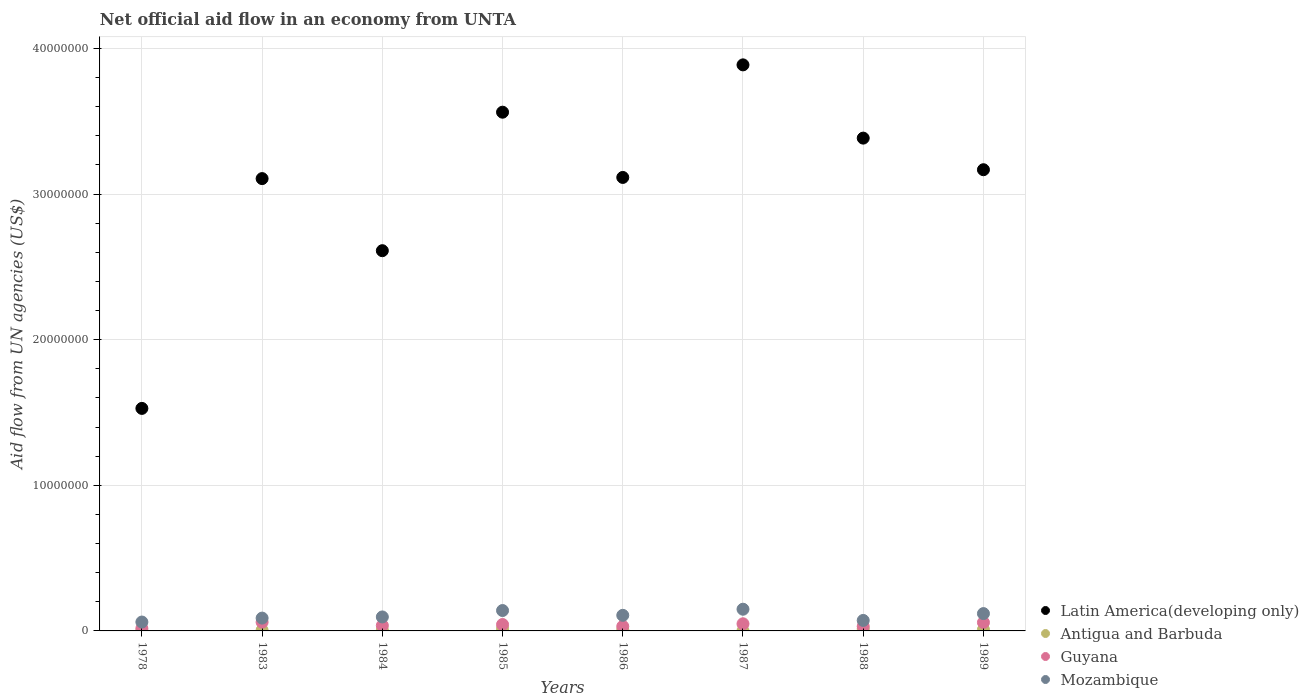What is the net official aid flow in Mozambique in 1983?
Ensure brevity in your answer.  8.80e+05. Across all years, what is the maximum net official aid flow in Antigua and Barbuda?
Provide a succinct answer. 1.60e+05. Across all years, what is the minimum net official aid flow in Mozambique?
Your answer should be compact. 6.10e+05. In which year was the net official aid flow in Guyana maximum?
Offer a terse response. 1983. In which year was the net official aid flow in Latin America(developing only) minimum?
Your answer should be very brief. 1978. What is the total net official aid flow in Mozambique in the graph?
Your response must be concise. 8.32e+06. What is the difference between the net official aid flow in Guyana in 1986 and the net official aid flow in Latin America(developing only) in 1987?
Provide a short and direct response. -3.86e+07. What is the average net official aid flow in Antigua and Barbuda per year?
Offer a very short reply. 7.50e+04. In the year 1978, what is the difference between the net official aid flow in Latin America(developing only) and net official aid flow in Mozambique?
Give a very brief answer. 1.47e+07. In how many years, is the net official aid flow in Mozambique greater than 6000000 US$?
Your answer should be very brief. 0. What is the ratio of the net official aid flow in Mozambique in 1985 to that in 1989?
Provide a succinct answer. 1.18. What is the difference between the highest and the lowest net official aid flow in Antigua and Barbuda?
Provide a succinct answer. 1.50e+05. In how many years, is the net official aid flow in Antigua and Barbuda greater than the average net official aid flow in Antigua and Barbuda taken over all years?
Give a very brief answer. 4. Is the sum of the net official aid flow in Antigua and Barbuda in 1985 and 1987 greater than the maximum net official aid flow in Mozambique across all years?
Your answer should be very brief. No. Is it the case that in every year, the sum of the net official aid flow in Mozambique and net official aid flow in Antigua and Barbuda  is greater than the sum of net official aid flow in Latin America(developing only) and net official aid flow in Guyana?
Offer a very short reply. No. Does the net official aid flow in Mozambique monotonically increase over the years?
Your answer should be compact. No. Is the net official aid flow in Guyana strictly greater than the net official aid flow in Antigua and Barbuda over the years?
Your answer should be very brief. Yes. Is the net official aid flow in Guyana strictly less than the net official aid flow in Mozambique over the years?
Your answer should be compact. Yes. How many dotlines are there?
Make the answer very short. 4. What is the difference between two consecutive major ticks on the Y-axis?
Give a very brief answer. 1.00e+07. Are the values on the major ticks of Y-axis written in scientific E-notation?
Your answer should be very brief. No. Does the graph contain grids?
Keep it short and to the point. Yes. Where does the legend appear in the graph?
Your response must be concise. Bottom right. How many legend labels are there?
Your answer should be very brief. 4. How are the legend labels stacked?
Make the answer very short. Vertical. What is the title of the graph?
Offer a very short reply. Net official aid flow in an economy from UNTA. Does "Sierra Leone" appear as one of the legend labels in the graph?
Offer a terse response. No. What is the label or title of the Y-axis?
Offer a terse response. Aid flow from UN agencies (US$). What is the Aid flow from UN agencies (US$) in Latin America(developing only) in 1978?
Offer a terse response. 1.53e+07. What is the Aid flow from UN agencies (US$) of Antigua and Barbuda in 1978?
Keep it short and to the point. 10000. What is the Aid flow from UN agencies (US$) in Guyana in 1978?
Ensure brevity in your answer.  1.70e+05. What is the Aid flow from UN agencies (US$) in Mozambique in 1978?
Your answer should be very brief. 6.10e+05. What is the Aid flow from UN agencies (US$) in Latin America(developing only) in 1983?
Make the answer very short. 3.11e+07. What is the Aid flow from UN agencies (US$) of Mozambique in 1983?
Your answer should be compact. 8.80e+05. What is the Aid flow from UN agencies (US$) of Latin America(developing only) in 1984?
Your answer should be very brief. 2.61e+07. What is the Aid flow from UN agencies (US$) of Antigua and Barbuda in 1984?
Ensure brevity in your answer.  6.00e+04. What is the Aid flow from UN agencies (US$) of Mozambique in 1984?
Provide a short and direct response. 9.60e+05. What is the Aid flow from UN agencies (US$) of Latin America(developing only) in 1985?
Provide a short and direct response. 3.56e+07. What is the Aid flow from UN agencies (US$) in Guyana in 1985?
Your response must be concise. 4.40e+05. What is the Aid flow from UN agencies (US$) in Mozambique in 1985?
Give a very brief answer. 1.40e+06. What is the Aid flow from UN agencies (US$) in Latin America(developing only) in 1986?
Your answer should be very brief. 3.11e+07. What is the Aid flow from UN agencies (US$) of Guyana in 1986?
Offer a very short reply. 3.10e+05. What is the Aid flow from UN agencies (US$) of Mozambique in 1986?
Provide a short and direct response. 1.07e+06. What is the Aid flow from UN agencies (US$) of Latin America(developing only) in 1987?
Give a very brief answer. 3.89e+07. What is the Aid flow from UN agencies (US$) in Mozambique in 1987?
Your response must be concise. 1.49e+06. What is the Aid flow from UN agencies (US$) in Latin America(developing only) in 1988?
Ensure brevity in your answer.  3.38e+07. What is the Aid flow from UN agencies (US$) of Antigua and Barbuda in 1988?
Provide a succinct answer. 1.40e+05. What is the Aid flow from UN agencies (US$) of Mozambique in 1988?
Your answer should be compact. 7.20e+05. What is the Aid flow from UN agencies (US$) of Latin America(developing only) in 1989?
Make the answer very short. 3.17e+07. What is the Aid flow from UN agencies (US$) in Guyana in 1989?
Your answer should be compact. 5.80e+05. What is the Aid flow from UN agencies (US$) of Mozambique in 1989?
Offer a very short reply. 1.19e+06. Across all years, what is the maximum Aid flow from UN agencies (US$) of Latin America(developing only)?
Provide a succinct answer. 3.89e+07. Across all years, what is the maximum Aid flow from UN agencies (US$) in Antigua and Barbuda?
Make the answer very short. 1.60e+05. Across all years, what is the maximum Aid flow from UN agencies (US$) in Mozambique?
Keep it short and to the point. 1.49e+06. Across all years, what is the minimum Aid flow from UN agencies (US$) in Latin America(developing only)?
Provide a short and direct response. 1.53e+07. What is the total Aid flow from UN agencies (US$) of Latin America(developing only) in the graph?
Your answer should be compact. 2.44e+08. What is the total Aid flow from UN agencies (US$) of Guyana in the graph?
Your response must be concise. 3.27e+06. What is the total Aid flow from UN agencies (US$) of Mozambique in the graph?
Provide a short and direct response. 8.32e+06. What is the difference between the Aid flow from UN agencies (US$) in Latin America(developing only) in 1978 and that in 1983?
Your response must be concise. -1.58e+07. What is the difference between the Aid flow from UN agencies (US$) of Antigua and Barbuda in 1978 and that in 1983?
Give a very brief answer. -4.00e+04. What is the difference between the Aid flow from UN agencies (US$) of Guyana in 1978 and that in 1983?
Offer a terse response. -4.30e+05. What is the difference between the Aid flow from UN agencies (US$) in Latin America(developing only) in 1978 and that in 1984?
Provide a short and direct response. -1.08e+07. What is the difference between the Aid flow from UN agencies (US$) in Mozambique in 1978 and that in 1984?
Keep it short and to the point. -3.50e+05. What is the difference between the Aid flow from UN agencies (US$) in Latin America(developing only) in 1978 and that in 1985?
Ensure brevity in your answer.  -2.03e+07. What is the difference between the Aid flow from UN agencies (US$) of Mozambique in 1978 and that in 1985?
Offer a terse response. -7.90e+05. What is the difference between the Aid flow from UN agencies (US$) in Latin America(developing only) in 1978 and that in 1986?
Keep it short and to the point. -1.59e+07. What is the difference between the Aid flow from UN agencies (US$) of Antigua and Barbuda in 1978 and that in 1986?
Provide a succinct answer. -7.00e+04. What is the difference between the Aid flow from UN agencies (US$) in Mozambique in 1978 and that in 1986?
Your answer should be compact. -4.60e+05. What is the difference between the Aid flow from UN agencies (US$) in Latin America(developing only) in 1978 and that in 1987?
Keep it short and to the point. -2.36e+07. What is the difference between the Aid flow from UN agencies (US$) in Antigua and Barbuda in 1978 and that in 1987?
Your answer should be very brief. 0. What is the difference between the Aid flow from UN agencies (US$) of Guyana in 1978 and that in 1987?
Your answer should be very brief. -3.20e+05. What is the difference between the Aid flow from UN agencies (US$) of Mozambique in 1978 and that in 1987?
Keep it short and to the point. -8.80e+05. What is the difference between the Aid flow from UN agencies (US$) in Latin America(developing only) in 1978 and that in 1988?
Offer a terse response. -1.86e+07. What is the difference between the Aid flow from UN agencies (US$) of Antigua and Barbuda in 1978 and that in 1988?
Your answer should be very brief. -1.30e+05. What is the difference between the Aid flow from UN agencies (US$) in Latin America(developing only) in 1978 and that in 1989?
Your answer should be compact. -1.64e+07. What is the difference between the Aid flow from UN agencies (US$) in Antigua and Barbuda in 1978 and that in 1989?
Your answer should be very brief. -8.00e+04. What is the difference between the Aid flow from UN agencies (US$) in Guyana in 1978 and that in 1989?
Keep it short and to the point. -4.10e+05. What is the difference between the Aid flow from UN agencies (US$) in Mozambique in 1978 and that in 1989?
Give a very brief answer. -5.80e+05. What is the difference between the Aid flow from UN agencies (US$) in Latin America(developing only) in 1983 and that in 1984?
Give a very brief answer. 4.95e+06. What is the difference between the Aid flow from UN agencies (US$) of Mozambique in 1983 and that in 1984?
Provide a succinct answer. -8.00e+04. What is the difference between the Aid flow from UN agencies (US$) of Latin America(developing only) in 1983 and that in 1985?
Offer a terse response. -4.56e+06. What is the difference between the Aid flow from UN agencies (US$) of Antigua and Barbuda in 1983 and that in 1985?
Keep it short and to the point. -1.10e+05. What is the difference between the Aid flow from UN agencies (US$) of Guyana in 1983 and that in 1985?
Your response must be concise. 1.60e+05. What is the difference between the Aid flow from UN agencies (US$) in Mozambique in 1983 and that in 1985?
Keep it short and to the point. -5.20e+05. What is the difference between the Aid flow from UN agencies (US$) in Latin America(developing only) in 1983 and that in 1986?
Your answer should be very brief. -8.00e+04. What is the difference between the Aid flow from UN agencies (US$) of Latin America(developing only) in 1983 and that in 1987?
Offer a very short reply. -7.81e+06. What is the difference between the Aid flow from UN agencies (US$) of Guyana in 1983 and that in 1987?
Provide a succinct answer. 1.10e+05. What is the difference between the Aid flow from UN agencies (US$) in Mozambique in 1983 and that in 1987?
Give a very brief answer. -6.10e+05. What is the difference between the Aid flow from UN agencies (US$) in Latin America(developing only) in 1983 and that in 1988?
Provide a succinct answer. -2.78e+06. What is the difference between the Aid flow from UN agencies (US$) of Mozambique in 1983 and that in 1988?
Provide a succinct answer. 1.60e+05. What is the difference between the Aid flow from UN agencies (US$) in Latin America(developing only) in 1983 and that in 1989?
Make the answer very short. -6.10e+05. What is the difference between the Aid flow from UN agencies (US$) of Guyana in 1983 and that in 1989?
Ensure brevity in your answer.  2.00e+04. What is the difference between the Aid flow from UN agencies (US$) in Mozambique in 1983 and that in 1989?
Provide a short and direct response. -3.10e+05. What is the difference between the Aid flow from UN agencies (US$) of Latin America(developing only) in 1984 and that in 1985?
Provide a succinct answer. -9.51e+06. What is the difference between the Aid flow from UN agencies (US$) of Mozambique in 1984 and that in 1985?
Keep it short and to the point. -4.40e+05. What is the difference between the Aid flow from UN agencies (US$) in Latin America(developing only) in 1984 and that in 1986?
Provide a succinct answer. -5.03e+06. What is the difference between the Aid flow from UN agencies (US$) of Guyana in 1984 and that in 1986?
Provide a succinct answer. 6.00e+04. What is the difference between the Aid flow from UN agencies (US$) in Mozambique in 1984 and that in 1986?
Offer a terse response. -1.10e+05. What is the difference between the Aid flow from UN agencies (US$) in Latin America(developing only) in 1984 and that in 1987?
Your answer should be very brief. -1.28e+07. What is the difference between the Aid flow from UN agencies (US$) of Mozambique in 1984 and that in 1987?
Your answer should be compact. -5.30e+05. What is the difference between the Aid flow from UN agencies (US$) of Latin America(developing only) in 1984 and that in 1988?
Your answer should be compact. -7.73e+06. What is the difference between the Aid flow from UN agencies (US$) in Guyana in 1984 and that in 1988?
Your answer should be very brief. 6.00e+04. What is the difference between the Aid flow from UN agencies (US$) in Latin America(developing only) in 1984 and that in 1989?
Offer a very short reply. -5.56e+06. What is the difference between the Aid flow from UN agencies (US$) of Antigua and Barbuda in 1984 and that in 1989?
Provide a succinct answer. -3.00e+04. What is the difference between the Aid flow from UN agencies (US$) of Latin America(developing only) in 1985 and that in 1986?
Offer a terse response. 4.48e+06. What is the difference between the Aid flow from UN agencies (US$) in Guyana in 1985 and that in 1986?
Your response must be concise. 1.30e+05. What is the difference between the Aid flow from UN agencies (US$) of Latin America(developing only) in 1985 and that in 1987?
Your response must be concise. -3.25e+06. What is the difference between the Aid flow from UN agencies (US$) in Antigua and Barbuda in 1985 and that in 1987?
Your answer should be very brief. 1.50e+05. What is the difference between the Aid flow from UN agencies (US$) of Guyana in 1985 and that in 1987?
Your answer should be very brief. -5.00e+04. What is the difference between the Aid flow from UN agencies (US$) in Latin America(developing only) in 1985 and that in 1988?
Offer a very short reply. 1.78e+06. What is the difference between the Aid flow from UN agencies (US$) in Antigua and Barbuda in 1985 and that in 1988?
Keep it short and to the point. 2.00e+04. What is the difference between the Aid flow from UN agencies (US$) in Guyana in 1985 and that in 1988?
Provide a succinct answer. 1.30e+05. What is the difference between the Aid flow from UN agencies (US$) in Mozambique in 1985 and that in 1988?
Your answer should be compact. 6.80e+05. What is the difference between the Aid flow from UN agencies (US$) of Latin America(developing only) in 1985 and that in 1989?
Your answer should be very brief. 3.95e+06. What is the difference between the Aid flow from UN agencies (US$) in Antigua and Barbuda in 1985 and that in 1989?
Your answer should be compact. 7.00e+04. What is the difference between the Aid flow from UN agencies (US$) of Mozambique in 1985 and that in 1989?
Ensure brevity in your answer.  2.10e+05. What is the difference between the Aid flow from UN agencies (US$) of Latin America(developing only) in 1986 and that in 1987?
Provide a succinct answer. -7.73e+06. What is the difference between the Aid flow from UN agencies (US$) in Mozambique in 1986 and that in 1987?
Your answer should be very brief. -4.20e+05. What is the difference between the Aid flow from UN agencies (US$) of Latin America(developing only) in 1986 and that in 1988?
Keep it short and to the point. -2.70e+06. What is the difference between the Aid flow from UN agencies (US$) of Antigua and Barbuda in 1986 and that in 1988?
Give a very brief answer. -6.00e+04. What is the difference between the Aid flow from UN agencies (US$) in Guyana in 1986 and that in 1988?
Your answer should be very brief. 0. What is the difference between the Aid flow from UN agencies (US$) of Mozambique in 1986 and that in 1988?
Offer a terse response. 3.50e+05. What is the difference between the Aid flow from UN agencies (US$) in Latin America(developing only) in 1986 and that in 1989?
Ensure brevity in your answer.  -5.30e+05. What is the difference between the Aid flow from UN agencies (US$) in Guyana in 1986 and that in 1989?
Keep it short and to the point. -2.70e+05. What is the difference between the Aid flow from UN agencies (US$) in Latin America(developing only) in 1987 and that in 1988?
Your answer should be very brief. 5.03e+06. What is the difference between the Aid flow from UN agencies (US$) of Antigua and Barbuda in 1987 and that in 1988?
Your answer should be compact. -1.30e+05. What is the difference between the Aid flow from UN agencies (US$) of Mozambique in 1987 and that in 1988?
Make the answer very short. 7.70e+05. What is the difference between the Aid flow from UN agencies (US$) of Latin America(developing only) in 1987 and that in 1989?
Give a very brief answer. 7.20e+06. What is the difference between the Aid flow from UN agencies (US$) in Mozambique in 1987 and that in 1989?
Provide a short and direct response. 3.00e+05. What is the difference between the Aid flow from UN agencies (US$) in Latin America(developing only) in 1988 and that in 1989?
Keep it short and to the point. 2.17e+06. What is the difference between the Aid flow from UN agencies (US$) in Antigua and Barbuda in 1988 and that in 1989?
Make the answer very short. 5.00e+04. What is the difference between the Aid flow from UN agencies (US$) in Guyana in 1988 and that in 1989?
Your response must be concise. -2.70e+05. What is the difference between the Aid flow from UN agencies (US$) in Mozambique in 1988 and that in 1989?
Provide a succinct answer. -4.70e+05. What is the difference between the Aid flow from UN agencies (US$) in Latin America(developing only) in 1978 and the Aid flow from UN agencies (US$) in Antigua and Barbuda in 1983?
Make the answer very short. 1.52e+07. What is the difference between the Aid flow from UN agencies (US$) in Latin America(developing only) in 1978 and the Aid flow from UN agencies (US$) in Guyana in 1983?
Offer a terse response. 1.47e+07. What is the difference between the Aid flow from UN agencies (US$) of Latin America(developing only) in 1978 and the Aid flow from UN agencies (US$) of Mozambique in 1983?
Make the answer very short. 1.44e+07. What is the difference between the Aid flow from UN agencies (US$) of Antigua and Barbuda in 1978 and the Aid flow from UN agencies (US$) of Guyana in 1983?
Your response must be concise. -5.90e+05. What is the difference between the Aid flow from UN agencies (US$) of Antigua and Barbuda in 1978 and the Aid flow from UN agencies (US$) of Mozambique in 1983?
Keep it short and to the point. -8.70e+05. What is the difference between the Aid flow from UN agencies (US$) in Guyana in 1978 and the Aid flow from UN agencies (US$) in Mozambique in 1983?
Provide a short and direct response. -7.10e+05. What is the difference between the Aid flow from UN agencies (US$) of Latin America(developing only) in 1978 and the Aid flow from UN agencies (US$) of Antigua and Barbuda in 1984?
Provide a short and direct response. 1.52e+07. What is the difference between the Aid flow from UN agencies (US$) in Latin America(developing only) in 1978 and the Aid flow from UN agencies (US$) in Guyana in 1984?
Give a very brief answer. 1.49e+07. What is the difference between the Aid flow from UN agencies (US$) of Latin America(developing only) in 1978 and the Aid flow from UN agencies (US$) of Mozambique in 1984?
Ensure brevity in your answer.  1.43e+07. What is the difference between the Aid flow from UN agencies (US$) of Antigua and Barbuda in 1978 and the Aid flow from UN agencies (US$) of Guyana in 1984?
Provide a succinct answer. -3.60e+05. What is the difference between the Aid flow from UN agencies (US$) of Antigua and Barbuda in 1978 and the Aid flow from UN agencies (US$) of Mozambique in 1984?
Your response must be concise. -9.50e+05. What is the difference between the Aid flow from UN agencies (US$) of Guyana in 1978 and the Aid flow from UN agencies (US$) of Mozambique in 1984?
Offer a very short reply. -7.90e+05. What is the difference between the Aid flow from UN agencies (US$) of Latin America(developing only) in 1978 and the Aid flow from UN agencies (US$) of Antigua and Barbuda in 1985?
Your response must be concise. 1.51e+07. What is the difference between the Aid flow from UN agencies (US$) in Latin America(developing only) in 1978 and the Aid flow from UN agencies (US$) in Guyana in 1985?
Make the answer very short. 1.48e+07. What is the difference between the Aid flow from UN agencies (US$) of Latin America(developing only) in 1978 and the Aid flow from UN agencies (US$) of Mozambique in 1985?
Provide a succinct answer. 1.39e+07. What is the difference between the Aid flow from UN agencies (US$) of Antigua and Barbuda in 1978 and the Aid flow from UN agencies (US$) of Guyana in 1985?
Your answer should be compact. -4.30e+05. What is the difference between the Aid flow from UN agencies (US$) in Antigua and Barbuda in 1978 and the Aid flow from UN agencies (US$) in Mozambique in 1985?
Make the answer very short. -1.39e+06. What is the difference between the Aid flow from UN agencies (US$) of Guyana in 1978 and the Aid flow from UN agencies (US$) of Mozambique in 1985?
Provide a short and direct response. -1.23e+06. What is the difference between the Aid flow from UN agencies (US$) in Latin America(developing only) in 1978 and the Aid flow from UN agencies (US$) in Antigua and Barbuda in 1986?
Provide a succinct answer. 1.52e+07. What is the difference between the Aid flow from UN agencies (US$) of Latin America(developing only) in 1978 and the Aid flow from UN agencies (US$) of Guyana in 1986?
Offer a terse response. 1.50e+07. What is the difference between the Aid flow from UN agencies (US$) of Latin America(developing only) in 1978 and the Aid flow from UN agencies (US$) of Mozambique in 1986?
Provide a short and direct response. 1.42e+07. What is the difference between the Aid flow from UN agencies (US$) in Antigua and Barbuda in 1978 and the Aid flow from UN agencies (US$) in Guyana in 1986?
Your response must be concise. -3.00e+05. What is the difference between the Aid flow from UN agencies (US$) of Antigua and Barbuda in 1978 and the Aid flow from UN agencies (US$) of Mozambique in 1986?
Provide a succinct answer. -1.06e+06. What is the difference between the Aid flow from UN agencies (US$) of Guyana in 1978 and the Aid flow from UN agencies (US$) of Mozambique in 1986?
Your response must be concise. -9.00e+05. What is the difference between the Aid flow from UN agencies (US$) in Latin America(developing only) in 1978 and the Aid flow from UN agencies (US$) in Antigua and Barbuda in 1987?
Provide a short and direct response. 1.53e+07. What is the difference between the Aid flow from UN agencies (US$) in Latin America(developing only) in 1978 and the Aid flow from UN agencies (US$) in Guyana in 1987?
Give a very brief answer. 1.48e+07. What is the difference between the Aid flow from UN agencies (US$) in Latin America(developing only) in 1978 and the Aid flow from UN agencies (US$) in Mozambique in 1987?
Ensure brevity in your answer.  1.38e+07. What is the difference between the Aid flow from UN agencies (US$) in Antigua and Barbuda in 1978 and the Aid flow from UN agencies (US$) in Guyana in 1987?
Offer a very short reply. -4.80e+05. What is the difference between the Aid flow from UN agencies (US$) in Antigua and Barbuda in 1978 and the Aid flow from UN agencies (US$) in Mozambique in 1987?
Provide a succinct answer. -1.48e+06. What is the difference between the Aid flow from UN agencies (US$) of Guyana in 1978 and the Aid flow from UN agencies (US$) of Mozambique in 1987?
Offer a very short reply. -1.32e+06. What is the difference between the Aid flow from UN agencies (US$) of Latin America(developing only) in 1978 and the Aid flow from UN agencies (US$) of Antigua and Barbuda in 1988?
Your response must be concise. 1.51e+07. What is the difference between the Aid flow from UN agencies (US$) in Latin America(developing only) in 1978 and the Aid flow from UN agencies (US$) in Guyana in 1988?
Provide a succinct answer. 1.50e+07. What is the difference between the Aid flow from UN agencies (US$) of Latin America(developing only) in 1978 and the Aid flow from UN agencies (US$) of Mozambique in 1988?
Keep it short and to the point. 1.46e+07. What is the difference between the Aid flow from UN agencies (US$) in Antigua and Barbuda in 1978 and the Aid flow from UN agencies (US$) in Mozambique in 1988?
Provide a succinct answer. -7.10e+05. What is the difference between the Aid flow from UN agencies (US$) of Guyana in 1978 and the Aid flow from UN agencies (US$) of Mozambique in 1988?
Offer a terse response. -5.50e+05. What is the difference between the Aid flow from UN agencies (US$) in Latin America(developing only) in 1978 and the Aid flow from UN agencies (US$) in Antigua and Barbuda in 1989?
Offer a terse response. 1.52e+07. What is the difference between the Aid flow from UN agencies (US$) in Latin America(developing only) in 1978 and the Aid flow from UN agencies (US$) in Guyana in 1989?
Provide a short and direct response. 1.47e+07. What is the difference between the Aid flow from UN agencies (US$) in Latin America(developing only) in 1978 and the Aid flow from UN agencies (US$) in Mozambique in 1989?
Keep it short and to the point. 1.41e+07. What is the difference between the Aid flow from UN agencies (US$) of Antigua and Barbuda in 1978 and the Aid flow from UN agencies (US$) of Guyana in 1989?
Provide a short and direct response. -5.70e+05. What is the difference between the Aid flow from UN agencies (US$) in Antigua and Barbuda in 1978 and the Aid flow from UN agencies (US$) in Mozambique in 1989?
Make the answer very short. -1.18e+06. What is the difference between the Aid flow from UN agencies (US$) of Guyana in 1978 and the Aid flow from UN agencies (US$) of Mozambique in 1989?
Your answer should be compact. -1.02e+06. What is the difference between the Aid flow from UN agencies (US$) of Latin America(developing only) in 1983 and the Aid flow from UN agencies (US$) of Antigua and Barbuda in 1984?
Ensure brevity in your answer.  3.10e+07. What is the difference between the Aid flow from UN agencies (US$) in Latin America(developing only) in 1983 and the Aid flow from UN agencies (US$) in Guyana in 1984?
Provide a succinct answer. 3.07e+07. What is the difference between the Aid flow from UN agencies (US$) in Latin America(developing only) in 1983 and the Aid flow from UN agencies (US$) in Mozambique in 1984?
Provide a short and direct response. 3.01e+07. What is the difference between the Aid flow from UN agencies (US$) in Antigua and Barbuda in 1983 and the Aid flow from UN agencies (US$) in Guyana in 1984?
Offer a very short reply. -3.20e+05. What is the difference between the Aid flow from UN agencies (US$) of Antigua and Barbuda in 1983 and the Aid flow from UN agencies (US$) of Mozambique in 1984?
Provide a short and direct response. -9.10e+05. What is the difference between the Aid flow from UN agencies (US$) of Guyana in 1983 and the Aid flow from UN agencies (US$) of Mozambique in 1984?
Your answer should be very brief. -3.60e+05. What is the difference between the Aid flow from UN agencies (US$) of Latin America(developing only) in 1983 and the Aid flow from UN agencies (US$) of Antigua and Barbuda in 1985?
Offer a very short reply. 3.09e+07. What is the difference between the Aid flow from UN agencies (US$) in Latin America(developing only) in 1983 and the Aid flow from UN agencies (US$) in Guyana in 1985?
Keep it short and to the point. 3.06e+07. What is the difference between the Aid flow from UN agencies (US$) of Latin America(developing only) in 1983 and the Aid flow from UN agencies (US$) of Mozambique in 1985?
Provide a short and direct response. 2.97e+07. What is the difference between the Aid flow from UN agencies (US$) in Antigua and Barbuda in 1983 and the Aid flow from UN agencies (US$) in Guyana in 1985?
Your response must be concise. -3.90e+05. What is the difference between the Aid flow from UN agencies (US$) of Antigua and Barbuda in 1983 and the Aid flow from UN agencies (US$) of Mozambique in 1985?
Provide a succinct answer. -1.35e+06. What is the difference between the Aid flow from UN agencies (US$) in Guyana in 1983 and the Aid flow from UN agencies (US$) in Mozambique in 1985?
Make the answer very short. -8.00e+05. What is the difference between the Aid flow from UN agencies (US$) in Latin America(developing only) in 1983 and the Aid flow from UN agencies (US$) in Antigua and Barbuda in 1986?
Offer a terse response. 3.10e+07. What is the difference between the Aid flow from UN agencies (US$) in Latin America(developing only) in 1983 and the Aid flow from UN agencies (US$) in Guyana in 1986?
Your answer should be very brief. 3.08e+07. What is the difference between the Aid flow from UN agencies (US$) in Latin America(developing only) in 1983 and the Aid flow from UN agencies (US$) in Mozambique in 1986?
Offer a terse response. 3.00e+07. What is the difference between the Aid flow from UN agencies (US$) of Antigua and Barbuda in 1983 and the Aid flow from UN agencies (US$) of Guyana in 1986?
Your answer should be very brief. -2.60e+05. What is the difference between the Aid flow from UN agencies (US$) of Antigua and Barbuda in 1983 and the Aid flow from UN agencies (US$) of Mozambique in 1986?
Offer a terse response. -1.02e+06. What is the difference between the Aid flow from UN agencies (US$) in Guyana in 1983 and the Aid flow from UN agencies (US$) in Mozambique in 1986?
Offer a very short reply. -4.70e+05. What is the difference between the Aid flow from UN agencies (US$) in Latin America(developing only) in 1983 and the Aid flow from UN agencies (US$) in Antigua and Barbuda in 1987?
Your answer should be very brief. 3.10e+07. What is the difference between the Aid flow from UN agencies (US$) of Latin America(developing only) in 1983 and the Aid flow from UN agencies (US$) of Guyana in 1987?
Offer a very short reply. 3.06e+07. What is the difference between the Aid flow from UN agencies (US$) of Latin America(developing only) in 1983 and the Aid flow from UN agencies (US$) of Mozambique in 1987?
Make the answer very short. 2.96e+07. What is the difference between the Aid flow from UN agencies (US$) in Antigua and Barbuda in 1983 and the Aid flow from UN agencies (US$) in Guyana in 1987?
Ensure brevity in your answer.  -4.40e+05. What is the difference between the Aid flow from UN agencies (US$) of Antigua and Barbuda in 1983 and the Aid flow from UN agencies (US$) of Mozambique in 1987?
Your answer should be compact. -1.44e+06. What is the difference between the Aid flow from UN agencies (US$) of Guyana in 1983 and the Aid flow from UN agencies (US$) of Mozambique in 1987?
Ensure brevity in your answer.  -8.90e+05. What is the difference between the Aid flow from UN agencies (US$) of Latin America(developing only) in 1983 and the Aid flow from UN agencies (US$) of Antigua and Barbuda in 1988?
Make the answer very short. 3.09e+07. What is the difference between the Aid flow from UN agencies (US$) of Latin America(developing only) in 1983 and the Aid flow from UN agencies (US$) of Guyana in 1988?
Your answer should be very brief. 3.08e+07. What is the difference between the Aid flow from UN agencies (US$) of Latin America(developing only) in 1983 and the Aid flow from UN agencies (US$) of Mozambique in 1988?
Make the answer very short. 3.03e+07. What is the difference between the Aid flow from UN agencies (US$) of Antigua and Barbuda in 1983 and the Aid flow from UN agencies (US$) of Mozambique in 1988?
Ensure brevity in your answer.  -6.70e+05. What is the difference between the Aid flow from UN agencies (US$) in Latin America(developing only) in 1983 and the Aid flow from UN agencies (US$) in Antigua and Barbuda in 1989?
Your answer should be very brief. 3.10e+07. What is the difference between the Aid flow from UN agencies (US$) in Latin America(developing only) in 1983 and the Aid flow from UN agencies (US$) in Guyana in 1989?
Keep it short and to the point. 3.05e+07. What is the difference between the Aid flow from UN agencies (US$) in Latin America(developing only) in 1983 and the Aid flow from UN agencies (US$) in Mozambique in 1989?
Your answer should be compact. 2.99e+07. What is the difference between the Aid flow from UN agencies (US$) of Antigua and Barbuda in 1983 and the Aid flow from UN agencies (US$) of Guyana in 1989?
Offer a very short reply. -5.30e+05. What is the difference between the Aid flow from UN agencies (US$) in Antigua and Barbuda in 1983 and the Aid flow from UN agencies (US$) in Mozambique in 1989?
Ensure brevity in your answer.  -1.14e+06. What is the difference between the Aid flow from UN agencies (US$) of Guyana in 1983 and the Aid flow from UN agencies (US$) of Mozambique in 1989?
Provide a short and direct response. -5.90e+05. What is the difference between the Aid flow from UN agencies (US$) of Latin America(developing only) in 1984 and the Aid flow from UN agencies (US$) of Antigua and Barbuda in 1985?
Ensure brevity in your answer.  2.60e+07. What is the difference between the Aid flow from UN agencies (US$) of Latin America(developing only) in 1984 and the Aid flow from UN agencies (US$) of Guyana in 1985?
Offer a very short reply. 2.57e+07. What is the difference between the Aid flow from UN agencies (US$) in Latin America(developing only) in 1984 and the Aid flow from UN agencies (US$) in Mozambique in 1985?
Offer a very short reply. 2.47e+07. What is the difference between the Aid flow from UN agencies (US$) of Antigua and Barbuda in 1984 and the Aid flow from UN agencies (US$) of Guyana in 1985?
Your answer should be compact. -3.80e+05. What is the difference between the Aid flow from UN agencies (US$) in Antigua and Barbuda in 1984 and the Aid flow from UN agencies (US$) in Mozambique in 1985?
Give a very brief answer. -1.34e+06. What is the difference between the Aid flow from UN agencies (US$) in Guyana in 1984 and the Aid flow from UN agencies (US$) in Mozambique in 1985?
Offer a terse response. -1.03e+06. What is the difference between the Aid flow from UN agencies (US$) of Latin America(developing only) in 1984 and the Aid flow from UN agencies (US$) of Antigua and Barbuda in 1986?
Provide a short and direct response. 2.60e+07. What is the difference between the Aid flow from UN agencies (US$) in Latin America(developing only) in 1984 and the Aid flow from UN agencies (US$) in Guyana in 1986?
Provide a short and direct response. 2.58e+07. What is the difference between the Aid flow from UN agencies (US$) of Latin America(developing only) in 1984 and the Aid flow from UN agencies (US$) of Mozambique in 1986?
Your answer should be very brief. 2.50e+07. What is the difference between the Aid flow from UN agencies (US$) in Antigua and Barbuda in 1984 and the Aid flow from UN agencies (US$) in Guyana in 1986?
Your answer should be very brief. -2.50e+05. What is the difference between the Aid flow from UN agencies (US$) of Antigua and Barbuda in 1984 and the Aid flow from UN agencies (US$) of Mozambique in 1986?
Offer a terse response. -1.01e+06. What is the difference between the Aid flow from UN agencies (US$) of Guyana in 1984 and the Aid flow from UN agencies (US$) of Mozambique in 1986?
Provide a succinct answer. -7.00e+05. What is the difference between the Aid flow from UN agencies (US$) of Latin America(developing only) in 1984 and the Aid flow from UN agencies (US$) of Antigua and Barbuda in 1987?
Your answer should be very brief. 2.61e+07. What is the difference between the Aid flow from UN agencies (US$) in Latin America(developing only) in 1984 and the Aid flow from UN agencies (US$) in Guyana in 1987?
Keep it short and to the point. 2.56e+07. What is the difference between the Aid flow from UN agencies (US$) in Latin America(developing only) in 1984 and the Aid flow from UN agencies (US$) in Mozambique in 1987?
Give a very brief answer. 2.46e+07. What is the difference between the Aid flow from UN agencies (US$) of Antigua and Barbuda in 1984 and the Aid flow from UN agencies (US$) of Guyana in 1987?
Provide a succinct answer. -4.30e+05. What is the difference between the Aid flow from UN agencies (US$) of Antigua and Barbuda in 1984 and the Aid flow from UN agencies (US$) of Mozambique in 1987?
Provide a short and direct response. -1.43e+06. What is the difference between the Aid flow from UN agencies (US$) of Guyana in 1984 and the Aid flow from UN agencies (US$) of Mozambique in 1987?
Keep it short and to the point. -1.12e+06. What is the difference between the Aid flow from UN agencies (US$) of Latin America(developing only) in 1984 and the Aid flow from UN agencies (US$) of Antigua and Barbuda in 1988?
Provide a short and direct response. 2.60e+07. What is the difference between the Aid flow from UN agencies (US$) in Latin America(developing only) in 1984 and the Aid flow from UN agencies (US$) in Guyana in 1988?
Give a very brief answer. 2.58e+07. What is the difference between the Aid flow from UN agencies (US$) of Latin America(developing only) in 1984 and the Aid flow from UN agencies (US$) of Mozambique in 1988?
Make the answer very short. 2.54e+07. What is the difference between the Aid flow from UN agencies (US$) in Antigua and Barbuda in 1984 and the Aid flow from UN agencies (US$) in Mozambique in 1988?
Keep it short and to the point. -6.60e+05. What is the difference between the Aid flow from UN agencies (US$) in Guyana in 1984 and the Aid flow from UN agencies (US$) in Mozambique in 1988?
Your answer should be very brief. -3.50e+05. What is the difference between the Aid flow from UN agencies (US$) of Latin America(developing only) in 1984 and the Aid flow from UN agencies (US$) of Antigua and Barbuda in 1989?
Your response must be concise. 2.60e+07. What is the difference between the Aid flow from UN agencies (US$) of Latin America(developing only) in 1984 and the Aid flow from UN agencies (US$) of Guyana in 1989?
Provide a succinct answer. 2.55e+07. What is the difference between the Aid flow from UN agencies (US$) of Latin America(developing only) in 1984 and the Aid flow from UN agencies (US$) of Mozambique in 1989?
Keep it short and to the point. 2.49e+07. What is the difference between the Aid flow from UN agencies (US$) of Antigua and Barbuda in 1984 and the Aid flow from UN agencies (US$) of Guyana in 1989?
Your answer should be compact. -5.20e+05. What is the difference between the Aid flow from UN agencies (US$) in Antigua and Barbuda in 1984 and the Aid flow from UN agencies (US$) in Mozambique in 1989?
Keep it short and to the point. -1.13e+06. What is the difference between the Aid flow from UN agencies (US$) of Guyana in 1984 and the Aid flow from UN agencies (US$) of Mozambique in 1989?
Provide a short and direct response. -8.20e+05. What is the difference between the Aid flow from UN agencies (US$) of Latin America(developing only) in 1985 and the Aid flow from UN agencies (US$) of Antigua and Barbuda in 1986?
Give a very brief answer. 3.55e+07. What is the difference between the Aid flow from UN agencies (US$) in Latin America(developing only) in 1985 and the Aid flow from UN agencies (US$) in Guyana in 1986?
Your response must be concise. 3.53e+07. What is the difference between the Aid flow from UN agencies (US$) of Latin America(developing only) in 1985 and the Aid flow from UN agencies (US$) of Mozambique in 1986?
Give a very brief answer. 3.46e+07. What is the difference between the Aid flow from UN agencies (US$) in Antigua and Barbuda in 1985 and the Aid flow from UN agencies (US$) in Mozambique in 1986?
Your answer should be compact. -9.10e+05. What is the difference between the Aid flow from UN agencies (US$) in Guyana in 1985 and the Aid flow from UN agencies (US$) in Mozambique in 1986?
Give a very brief answer. -6.30e+05. What is the difference between the Aid flow from UN agencies (US$) of Latin America(developing only) in 1985 and the Aid flow from UN agencies (US$) of Antigua and Barbuda in 1987?
Your response must be concise. 3.56e+07. What is the difference between the Aid flow from UN agencies (US$) in Latin America(developing only) in 1985 and the Aid flow from UN agencies (US$) in Guyana in 1987?
Provide a succinct answer. 3.51e+07. What is the difference between the Aid flow from UN agencies (US$) of Latin America(developing only) in 1985 and the Aid flow from UN agencies (US$) of Mozambique in 1987?
Keep it short and to the point. 3.41e+07. What is the difference between the Aid flow from UN agencies (US$) in Antigua and Barbuda in 1985 and the Aid flow from UN agencies (US$) in Guyana in 1987?
Your response must be concise. -3.30e+05. What is the difference between the Aid flow from UN agencies (US$) in Antigua and Barbuda in 1985 and the Aid flow from UN agencies (US$) in Mozambique in 1987?
Make the answer very short. -1.33e+06. What is the difference between the Aid flow from UN agencies (US$) of Guyana in 1985 and the Aid flow from UN agencies (US$) of Mozambique in 1987?
Provide a short and direct response. -1.05e+06. What is the difference between the Aid flow from UN agencies (US$) of Latin America(developing only) in 1985 and the Aid flow from UN agencies (US$) of Antigua and Barbuda in 1988?
Your response must be concise. 3.55e+07. What is the difference between the Aid flow from UN agencies (US$) of Latin America(developing only) in 1985 and the Aid flow from UN agencies (US$) of Guyana in 1988?
Your answer should be very brief. 3.53e+07. What is the difference between the Aid flow from UN agencies (US$) in Latin America(developing only) in 1985 and the Aid flow from UN agencies (US$) in Mozambique in 1988?
Keep it short and to the point. 3.49e+07. What is the difference between the Aid flow from UN agencies (US$) of Antigua and Barbuda in 1985 and the Aid flow from UN agencies (US$) of Mozambique in 1988?
Provide a succinct answer. -5.60e+05. What is the difference between the Aid flow from UN agencies (US$) of Guyana in 1985 and the Aid flow from UN agencies (US$) of Mozambique in 1988?
Your answer should be compact. -2.80e+05. What is the difference between the Aid flow from UN agencies (US$) of Latin America(developing only) in 1985 and the Aid flow from UN agencies (US$) of Antigua and Barbuda in 1989?
Keep it short and to the point. 3.55e+07. What is the difference between the Aid flow from UN agencies (US$) of Latin America(developing only) in 1985 and the Aid flow from UN agencies (US$) of Guyana in 1989?
Ensure brevity in your answer.  3.50e+07. What is the difference between the Aid flow from UN agencies (US$) in Latin America(developing only) in 1985 and the Aid flow from UN agencies (US$) in Mozambique in 1989?
Provide a short and direct response. 3.44e+07. What is the difference between the Aid flow from UN agencies (US$) of Antigua and Barbuda in 1985 and the Aid flow from UN agencies (US$) of Guyana in 1989?
Give a very brief answer. -4.20e+05. What is the difference between the Aid flow from UN agencies (US$) in Antigua and Barbuda in 1985 and the Aid flow from UN agencies (US$) in Mozambique in 1989?
Your response must be concise. -1.03e+06. What is the difference between the Aid flow from UN agencies (US$) in Guyana in 1985 and the Aid flow from UN agencies (US$) in Mozambique in 1989?
Offer a terse response. -7.50e+05. What is the difference between the Aid flow from UN agencies (US$) in Latin America(developing only) in 1986 and the Aid flow from UN agencies (US$) in Antigua and Barbuda in 1987?
Ensure brevity in your answer.  3.11e+07. What is the difference between the Aid flow from UN agencies (US$) of Latin America(developing only) in 1986 and the Aid flow from UN agencies (US$) of Guyana in 1987?
Provide a succinct answer. 3.06e+07. What is the difference between the Aid flow from UN agencies (US$) of Latin America(developing only) in 1986 and the Aid flow from UN agencies (US$) of Mozambique in 1987?
Provide a succinct answer. 2.96e+07. What is the difference between the Aid flow from UN agencies (US$) in Antigua and Barbuda in 1986 and the Aid flow from UN agencies (US$) in Guyana in 1987?
Provide a succinct answer. -4.10e+05. What is the difference between the Aid flow from UN agencies (US$) in Antigua and Barbuda in 1986 and the Aid flow from UN agencies (US$) in Mozambique in 1987?
Offer a very short reply. -1.41e+06. What is the difference between the Aid flow from UN agencies (US$) in Guyana in 1986 and the Aid flow from UN agencies (US$) in Mozambique in 1987?
Your response must be concise. -1.18e+06. What is the difference between the Aid flow from UN agencies (US$) of Latin America(developing only) in 1986 and the Aid flow from UN agencies (US$) of Antigua and Barbuda in 1988?
Ensure brevity in your answer.  3.10e+07. What is the difference between the Aid flow from UN agencies (US$) in Latin America(developing only) in 1986 and the Aid flow from UN agencies (US$) in Guyana in 1988?
Offer a terse response. 3.08e+07. What is the difference between the Aid flow from UN agencies (US$) in Latin America(developing only) in 1986 and the Aid flow from UN agencies (US$) in Mozambique in 1988?
Your answer should be compact. 3.04e+07. What is the difference between the Aid flow from UN agencies (US$) of Antigua and Barbuda in 1986 and the Aid flow from UN agencies (US$) of Mozambique in 1988?
Offer a terse response. -6.40e+05. What is the difference between the Aid flow from UN agencies (US$) in Guyana in 1986 and the Aid flow from UN agencies (US$) in Mozambique in 1988?
Provide a short and direct response. -4.10e+05. What is the difference between the Aid flow from UN agencies (US$) of Latin America(developing only) in 1986 and the Aid flow from UN agencies (US$) of Antigua and Barbuda in 1989?
Ensure brevity in your answer.  3.10e+07. What is the difference between the Aid flow from UN agencies (US$) in Latin America(developing only) in 1986 and the Aid flow from UN agencies (US$) in Guyana in 1989?
Ensure brevity in your answer.  3.06e+07. What is the difference between the Aid flow from UN agencies (US$) in Latin America(developing only) in 1986 and the Aid flow from UN agencies (US$) in Mozambique in 1989?
Your answer should be compact. 3.00e+07. What is the difference between the Aid flow from UN agencies (US$) in Antigua and Barbuda in 1986 and the Aid flow from UN agencies (US$) in Guyana in 1989?
Your response must be concise. -5.00e+05. What is the difference between the Aid flow from UN agencies (US$) of Antigua and Barbuda in 1986 and the Aid flow from UN agencies (US$) of Mozambique in 1989?
Keep it short and to the point. -1.11e+06. What is the difference between the Aid flow from UN agencies (US$) of Guyana in 1986 and the Aid flow from UN agencies (US$) of Mozambique in 1989?
Make the answer very short. -8.80e+05. What is the difference between the Aid flow from UN agencies (US$) of Latin America(developing only) in 1987 and the Aid flow from UN agencies (US$) of Antigua and Barbuda in 1988?
Your response must be concise. 3.87e+07. What is the difference between the Aid flow from UN agencies (US$) of Latin America(developing only) in 1987 and the Aid flow from UN agencies (US$) of Guyana in 1988?
Give a very brief answer. 3.86e+07. What is the difference between the Aid flow from UN agencies (US$) in Latin America(developing only) in 1987 and the Aid flow from UN agencies (US$) in Mozambique in 1988?
Offer a very short reply. 3.82e+07. What is the difference between the Aid flow from UN agencies (US$) in Antigua and Barbuda in 1987 and the Aid flow from UN agencies (US$) in Guyana in 1988?
Ensure brevity in your answer.  -3.00e+05. What is the difference between the Aid flow from UN agencies (US$) of Antigua and Barbuda in 1987 and the Aid flow from UN agencies (US$) of Mozambique in 1988?
Offer a very short reply. -7.10e+05. What is the difference between the Aid flow from UN agencies (US$) of Guyana in 1987 and the Aid flow from UN agencies (US$) of Mozambique in 1988?
Offer a very short reply. -2.30e+05. What is the difference between the Aid flow from UN agencies (US$) in Latin America(developing only) in 1987 and the Aid flow from UN agencies (US$) in Antigua and Barbuda in 1989?
Give a very brief answer. 3.88e+07. What is the difference between the Aid flow from UN agencies (US$) of Latin America(developing only) in 1987 and the Aid flow from UN agencies (US$) of Guyana in 1989?
Offer a terse response. 3.83e+07. What is the difference between the Aid flow from UN agencies (US$) in Latin America(developing only) in 1987 and the Aid flow from UN agencies (US$) in Mozambique in 1989?
Your response must be concise. 3.77e+07. What is the difference between the Aid flow from UN agencies (US$) of Antigua and Barbuda in 1987 and the Aid flow from UN agencies (US$) of Guyana in 1989?
Keep it short and to the point. -5.70e+05. What is the difference between the Aid flow from UN agencies (US$) of Antigua and Barbuda in 1987 and the Aid flow from UN agencies (US$) of Mozambique in 1989?
Your answer should be very brief. -1.18e+06. What is the difference between the Aid flow from UN agencies (US$) in Guyana in 1987 and the Aid flow from UN agencies (US$) in Mozambique in 1989?
Offer a very short reply. -7.00e+05. What is the difference between the Aid flow from UN agencies (US$) in Latin America(developing only) in 1988 and the Aid flow from UN agencies (US$) in Antigua and Barbuda in 1989?
Keep it short and to the point. 3.38e+07. What is the difference between the Aid flow from UN agencies (US$) in Latin America(developing only) in 1988 and the Aid flow from UN agencies (US$) in Guyana in 1989?
Make the answer very short. 3.33e+07. What is the difference between the Aid flow from UN agencies (US$) in Latin America(developing only) in 1988 and the Aid flow from UN agencies (US$) in Mozambique in 1989?
Provide a succinct answer. 3.26e+07. What is the difference between the Aid flow from UN agencies (US$) of Antigua and Barbuda in 1988 and the Aid flow from UN agencies (US$) of Guyana in 1989?
Provide a short and direct response. -4.40e+05. What is the difference between the Aid flow from UN agencies (US$) of Antigua and Barbuda in 1988 and the Aid flow from UN agencies (US$) of Mozambique in 1989?
Provide a succinct answer. -1.05e+06. What is the difference between the Aid flow from UN agencies (US$) in Guyana in 1988 and the Aid flow from UN agencies (US$) in Mozambique in 1989?
Provide a short and direct response. -8.80e+05. What is the average Aid flow from UN agencies (US$) of Latin America(developing only) per year?
Keep it short and to the point. 3.04e+07. What is the average Aid flow from UN agencies (US$) of Antigua and Barbuda per year?
Give a very brief answer. 7.50e+04. What is the average Aid flow from UN agencies (US$) in Guyana per year?
Provide a short and direct response. 4.09e+05. What is the average Aid flow from UN agencies (US$) of Mozambique per year?
Your answer should be compact. 1.04e+06. In the year 1978, what is the difference between the Aid flow from UN agencies (US$) of Latin America(developing only) and Aid flow from UN agencies (US$) of Antigua and Barbuda?
Make the answer very short. 1.53e+07. In the year 1978, what is the difference between the Aid flow from UN agencies (US$) of Latin America(developing only) and Aid flow from UN agencies (US$) of Guyana?
Keep it short and to the point. 1.51e+07. In the year 1978, what is the difference between the Aid flow from UN agencies (US$) in Latin America(developing only) and Aid flow from UN agencies (US$) in Mozambique?
Keep it short and to the point. 1.47e+07. In the year 1978, what is the difference between the Aid flow from UN agencies (US$) of Antigua and Barbuda and Aid flow from UN agencies (US$) of Mozambique?
Provide a succinct answer. -6.00e+05. In the year 1978, what is the difference between the Aid flow from UN agencies (US$) in Guyana and Aid flow from UN agencies (US$) in Mozambique?
Offer a terse response. -4.40e+05. In the year 1983, what is the difference between the Aid flow from UN agencies (US$) of Latin America(developing only) and Aid flow from UN agencies (US$) of Antigua and Barbuda?
Your response must be concise. 3.10e+07. In the year 1983, what is the difference between the Aid flow from UN agencies (US$) of Latin America(developing only) and Aid flow from UN agencies (US$) of Guyana?
Offer a very short reply. 3.05e+07. In the year 1983, what is the difference between the Aid flow from UN agencies (US$) in Latin America(developing only) and Aid flow from UN agencies (US$) in Mozambique?
Your response must be concise. 3.02e+07. In the year 1983, what is the difference between the Aid flow from UN agencies (US$) in Antigua and Barbuda and Aid flow from UN agencies (US$) in Guyana?
Ensure brevity in your answer.  -5.50e+05. In the year 1983, what is the difference between the Aid flow from UN agencies (US$) of Antigua and Barbuda and Aid flow from UN agencies (US$) of Mozambique?
Your answer should be very brief. -8.30e+05. In the year 1983, what is the difference between the Aid flow from UN agencies (US$) in Guyana and Aid flow from UN agencies (US$) in Mozambique?
Make the answer very short. -2.80e+05. In the year 1984, what is the difference between the Aid flow from UN agencies (US$) of Latin America(developing only) and Aid flow from UN agencies (US$) of Antigua and Barbuda?
Make the answer very short. 2.60e+07. In the year 1984, what is the difference between the Aid flow from UN agencies (US$) in Latin America(developing only) and Aid flow from UN agencies (US$) in Guyana?
Offer a terse response. 2.57e+07. In the year 1984, what is the difference between the Aid flow from UN agencies (US$) in Latin America(developing only) and Aid flow from UN agencies (US$) in Mozambique?
Make the answer very short. 2.52e+07. In the year 1984, what is the difference between the Aid flow from UN agencies (US$) of Antigua and Barbuda and Aid flow from UN agencies (US$) of Guyana?
Provide a succinct answer. -3.10e+05. In the year 1984, what is the difference between the Aid flow from UN agencies (US$) in Antigua and Barbuda and Aid flow from UN agencies (US$) in Mozambique?
Offer a very short reply. -9.00e+05. In the year 1984, what is the difference between the Aid flow from UN agencies (US$) of Guyana and Aid flow from UN agencies (US$) of Mozambique?
Your answer should be compact. -5.90e+05. In the year 1985, what is the difference between the Aid flow from UN agencies (US$) of Latin America(developing only) and Aid flow from UN agencies (US$) of Antigua and Barbuda?
Your response must be concise. 3.55e+07. In the year 1985, what is the difference between the Aid flow from UN agencies (US$) in Latin America(developing only) and Aid flow from UN agencies (US$) in Guyana?
Keep it short and to the point. 3.52e+07. In the year 1985, what is the difference between the Aid flow from UN agencies (US$) of Latin America(developing only) and Aid flow from UN agencies (US$) of Mozambique?
Give a very brief answer. 3.42e+07. In the year 1985, what is the difference between the Aid flow from UN agencies (US$) in Antigua and Barbuda and Aid flow from UN agencies (US$) in Guyana?
Your answer should be very brief. -2.80e+05. In the year 1985, what is the difference between the Aid flow from UN agencies (US$) of Antigua and Barbuda and Aid flow from UN agencies (US$) of Mozambique?
Give a very brief answer. -1.24e+06. In the year 1985, what is the difference between the Aid flow from UN agencies (US$) in Guyana and Aid flow from UN agencies (US$) in Mozambique?
Offer a terse response. -9.60e+05. In the year 1986, what is the difference between the Aid flow from UN agencies (US$) of Latin America(developing only) and Aid flow from UN agencies (US$) of Antigua and Barbuda?
Offer a terse response. 3.11e+07. In the year 1986, what is the difference between the Aid flow from UN agencies (US$) in Latin America(developing only) and Aid flow from UN agencies (US$) in Guyana?
Keep it short and to the point. 3.08e+07. In the year 1986, what is the difference between the Aid flow from UN agencies (US$) of Latin America(developing only) and Aid flow from UN agencies (US$) of Mozambique?
Provide a short and direct response. 3.01e+07. In the year 1986, what is the difference between the Aid flow from UN agencies (US$) in Antigua and Barbuda and Aid flow from UN agencies (US$) in Mozambique?
Offer a very short reply. -9.90e+05. In the year 1986, what is the difference between the Aid flow from UN agencies (US$) in Guyana and Aid flow from UN agencies (US$) in Mozambique?
Your answer should be very brief. -7.60e+05. In the year 1987, what is the difference between the Aid flow from UN agencies (US$) of Latin America(developing only) and Aid flow from UN agencies (US$) of Antigua and Barbuda?
Offer a terse response. 3.89e+07. In the year 1987, what is the difference between the Aid flow from UN agencies (US$) in Latin America(developing only) and Aid flow from UN agencies (US$) in Guyana?
Keep it short and to the point. 3.84e+07. In the year 1987, what is the difference between the Aid flow from UN agencies (US$) of Latin America(developing only) and Aid flow from UN agencies (US$) of Mozambique?
Offer a terse response. 3.74e+07. In the year 1987, what is the difference between the Aid flow from UN agencies (US$) of Antigua and Barbuda and Aid flow from UN agencies (US$) of Guyana?
Offer a very short reply. -4.80e+05. In the year 1987, what is the difference between the Aid flow from UN agencies (US$) in Antigua and Barbuda and Aid flow from UN agencies (US$) in Mozambique?
Provide a succinct answer. -1.48e+06. In the year 1987, what is the difference between the Aid flow from UN agencies (US$) of Guyana and Aid flow from UN agencies (US$) of Mozambique?
Offer a terse response. -1.00e+06. In the year 1988, what is the difference between the Aid flow from UN agencies (US$) of Latin America(developing only) and Aid flow from UN agencies (US$) of Antigua and Barbuda?
Offer a terse response. 3.37e+07. In the year 1988, what is the difference between the Aid flow from UN agencies (US$) of Latin America(developing only) and Aid flow from UN agencies (US$) of Guyana?
Provide a short and direct response. 3.35e+07. In the year 1988, what is the difference between the Aid flow from UN agencies (US$) of Latin America(developing only) and Aid flow from UN agencies (US$) of Mozambique?
Offer a very short reply. 3.31e+07. In the year 1988, what is the difference between the Aid flow from UN agencies (US$) of Antigua and Barbuda and Aid flow from UN agencies (US$) of Guyana?
Your answer should be compact. -1.70e+05. In the year 1988, what is the difference between the Aid flow from UN agencies (US$) of Antigua and Barbuda and Aid flow from UN agencies (US$) of Mozambique?
Provide a succinct answer. -5.80e+05. In the year 1988, what is the difference between the Aid flow from UN agencies (US$) of Guyana and Aid flow from UN agencies (US$) of Mozambique?
Ensure brevity in your answer.  -4.10e+05. In the year 1989, what is the difference between the Aid flow from UN agencies (US$) of Latin America(developing only) and Aid flow from UN agencies (US$) of Antigua and Barbuda?
Keep it short and to the point. 3.16e+07. In the year 1989, what is the difference between the Aid flow from UN agencies (US$) in Latin America(developing only) and Aid flow from UN agencies (US$) in Guyana?
Make the answer very short. 3.11e+07. In the year 1989, what is the difference between the Aid flow from UN agencies (US$) of Latin America(developing only) and Aid flow from UN agencies (US$) of Mozambique?
Ensure brevity in your answer.  3.05e+07. In the year 1989, what is the difference between the Aid flow from UN agencies (US$) in Antigua and Barbuda and Aid flow from UN agencies (US$) in Guyana?
Keep it short and to the point. -4.90e+05. In the year 1989, what is the difference between the Aid flow from UN agencies (US$) in Antigua and Barbuda and Aid flow from UN agencies (US$) in Mozambique?
Your answer should be very brief. -1.10e+06. In the year 1989, what is the difference between the Aid flow from UN agencies (US$) in Guyana and Aid flow from UN agencies (US$) in Mozambique?
Keep it short and to the point. -6.10e+05. What is the ratio of the Aid flow from UN agencies (US$) of Latin America(developing only) in 1978 to that in 1983?
Your response must be concise. 0.49. What is the ratio of the Aid flow from UN agencies (US$) in Guyana in 1978 to that in 1983?
Your answer should be compact. 0.28. What is the ratio of the Aid flow from UN agencies (US$) of Mozambique in 1978 to that in 1983?
Your answer should be compact. 0.69. What is the ratio of the Aid flow from UN agencies (US$) in Latin America(developing only) in 1978 to that in 1984?
Provide a succinct answer. 0.59. What is the ratio of the Aid flow from UN agencies (US$) of Guyana in 1978 to that in 1984?
Give a very brief answer. 0.46. What is the ratio of the Aid flow from UN agencies (US$) of Mozambique in 1978 to that in 1984?
Keep it short and to the point. 0.64. What is the ratio of the Aid flow from UN agencies (US$) in Latin America(developing only) in 1978 to that in 1985?
Your answer should be very brief. 0.43. What is the ratio of the Aid flow from UN agencies (US$) in Antigua and Barbuda in 1978 to that in 1985?
Give a very brief answer. 0.06. What is the ratio of the Aid flow from UN agencies (US$) in Guyana in 1978 to that in 1985?
Offer a very short reply. 0.39. What is the ratio of the Aid flow from UN agencies (US$) of Mozambique in 1978 to that in 1985?
Your answer should be compact. 0.44. What is the ratio of the Aid flow from UN agencies (US$) of Latin America(developing only) in 1978 to that in 1986?
Provide a short and direct response. 0.49. What is the ratio of the Aid flow from UN agencies (US$) in Antigua and Barbuda in 1978 to that in 1986?
Make the answer very short. 0.12. What is the ratio of the Aid flow from UN agencies (US$) in Guyana in 1978 to that in 1986?
Your answer should be compact. 0.55. What is the ratio of the Aid flow from UN agencies (US$) in Mozambique in 1978 to that in 1986?
Your response must be concise. 0.57. What is the ratio of the Aid flow from UN agencies (US$) in Latin America(developing only) in 1978 to that in 1987?
Offer a terse response. 0.39. What is the ratio of the Aid flow from UN agencies (US$) of Guyana in 1978 to that in 1987?
Your answer should be very brief. 0.35. What is the ratio of the Aid flow from UN agencies (US$) of Mozambique in 1978 to that in 1987?
Your response must be concise. 0.41. What is the ratio of the Aid flow from UN agencies (US$) in Latin America(developing only) in 1978 to that in 1988?
Your response must be concise. 0.45. What is the ratio of the Aid flow from UN agencies (US$) of Antigua and Barbuda in 1978 to that in 1988?
Make the answer very short. 0.07. What is the ratio of the Aid flow from UN agencies (US$) in Guyana in 1978 to that in 1988?
Your answer should be compact. 0.55. What is the ratio of the Aid flow from UN agencies (US$) in Mozambique in 1978 to that in 1988?
Your answer should be compact. 0.85. What is the ratio of the Aid flow from UN agencies (US$) in Latin America(developing only) in 1978 to that in 1989?
Offer a terse response. 0.48. What is the ratio of the Aid flow from UN agencies (US$) in Guyana in 1978 to that in 1989?
Ensure brevity in your answer.  0.29. What is the ratio of the Aid flow from UN agencies (US$) of Mozambique in 1978 to that in 1989?
Offer a very short reply. 0.51. What is the ratio of the Aid flow from UN agencies (US$) in Latin America(developing only) in 1983 to that in 1984?
Your response must be concise. 1.19. What is the ratio of the Aid flow from UN agencies (US$) of Antigua and Barbuda in 1983 to that in 1984?
Give a very brief answer. 0.83. What is the ratio of the Aid flow from UN agencies (US$) in Guyana in 1983 to that in 1984?
Your answer should be very brief. 1.62. What is the ratio of the Aid flow from UN agencies (US$) in Mozambique in 1983 to that in 1984?
Give a very brief answer. 0.92. What is the ratio of the Aid flow from UN agencies (US$) of Latin America(developing only) in 1983 to that in 1985?
Make the answer very short. 0.87. What is the ratio of the Aid flow from UN agencies (US$) in Antigua and Barbuda in 1983 to that in 1985?
Provide a short and direct response. 0.31. What is the ratio of the Aid flow from UN agencies (US$) in Guyana in 1983 to that in 1985?
Your response must be concise. 1.36. What is the ratio of the Aid flow from UN agencies (US$) in Mozambique in 1983 to that in 1985?
Make the answer very short. 0.63. What is the ratio of the Aid flow from UN agencies (US$) of Latin America(developing only) in 1983 to that in 1986?
Make the answer very short. 1. What is the ratio of the Aid flow from UN agencies (US$) of Antigua and Barbuda in 1983 to that in 1986?
Offer a terse response. 0.62. What is the ratio of the Aid flow from UN agencies (US$) in Guyana in 1983 to that in 1986?
Offer a very short reply. 1.94. What is the ratio of the Aid flow from UN agencies (US$) of Mozambique in 1983 to that in 1986?
Provide a short and direct response. 0.82. What is the ratio of the Aid flow from UN agencies (US$) in Latin America(developing only) in 1983 to that in 1987?
Make the answer very short. 0.8. What is the ratio of the Aid flow from UN agencies (US$) of Antigua and Barbuda in 1983 to that in 1987?
Provide a short and direct response. 5. What is the ratio of the Aid flow from UN agencies (US$) of Guyana in 1983 to that in 1987?
Offer a terse response. 1.22. What is the ratio of the Aid flow from UN agencies (US$) in Mozambique in 1983 to that in 1987?
Make the answer very short. 0.59. What is the ratio of the Aid flow from UN agencies (US$) in Latin America(developing only) in 1983 to that in 1988?
Ensure brevity in your answer.  0.92. What is the ratio of the Aid flow from UN agencies (US$) in Antigua and Barbuda in 1983 to that in 1988?
Offer a very short reply. 0.36. What is the ratio of the Aid flow from UN agencies (US$) in Guyana in 1983 to that in 1988?
Your response must be concise. 1.94. What is the ratio of the Aid flow from UN agencies (US$) in Mozambique in 1983 to that in 1988?
Offer a terse response. 1.22. What is the ratio of the Aid flow from UN agencies (US$) of Latin America(developing only) in 1983 to that in 1989?
Give a very brief answer. 0.98. What is the ratio of the Aid flow from UN agencies (US$) in Antigua and Barbuda in 1983 to that in 1989?
Give a very brief answer. 0.56. What is the ratio of the Aid flow from UN agencies (US$) of Guyana in 1983 to that in 1989?
Provide a succinct answer. 1.03. What is the ratio of the Aid flow from UN agencies (US$) of Mozambique in 1983 to that in 1989?
Ensure brevity in your answer.  0.74. What is the ratio of the Aid flow from UN agencies (US$) of Latin America(developing only) in 1984 to that in 1985?
Your response must be concise. 0.73. What is the ratio of the Aid flow from UN agencies (US$) in Antigua and Barbuda in 1984 to that in 1985?
Keep it short and to the point. 0.38. What is the ratio of the Aid flow from UN agencies (US$) of Guyana in 1984 to that in 1985?
Your answer should be very brief. 0.84. What is the ratio of the Aid flow from UN agencies (US$) of Mozambique in 1984 to that in 1985?
Your response must be concise. 0.69. What is the ratio of the Aid flow from UN agencies (US$) of Latin America(developing only) in 1984 to that in 1986?
Offer a very short reply. 0.84. What is the ratio of the Aid flow from UN agencies (US$) in Guyana in 1984 to that in 1986?
Keep it short and to the point. 1.19. What is the ratio of the Aid flow from UN agencies (US$) in Mozambique in 1984 to that in 1986?
Keep it short and to the point. 0.9. What is the ratio of the Aid flow from UN agencies (US$) of Latin America(developing only) in 1984 to that in 1987?
Offer a very short reply. 0.67. What is the ratio of the Aid flow from UN agencies (US$) of Guyana in 1984 to that in 1987?
Provide a succinct answer. 0.76. What is the ratio of the Aid flow from UN agencies (US$) in Mozambique in 1984 to that in 1987?
Make the answer very short. 0.64. What is the ratio of the Aid flow from UN agencies (US$) of Latin America(developing only) in 1984 to that in 1988?
Your response must be concise. 0.77. What is the ratio of the Aid flow from UN agencies (US$) of Antigua and Barbuda in 1984 to that in 1988?
Give a very brief answer. 0.43. What is the ratio of the Aid flow from UN agencies (US$) in Guyana in 1984 to that in 1988?
Provide a short and direct response. 1.19. What is the ratio of the Aid flow from UN agencies (US$) of Mozambique in 1984 to that in 1988?
Ensure brevity in your answer.  1.33. What is the ratio of the Aid flow from UN agencies (US$) in Latin America(developing only) in 1984 to that in 1989?
Offer a terse response. 0.82. What is the ratio of the Aid flow from UN agencies (US$) of Antigua and Barbuda in 1984 to that in 1989?
Give a very brief answer. 0.67. What is the ratio of the Aid flow from UN agencies (US$) in Guyana in 1984 to that in 1989?
Your response must be concise. 0.64. What is the ratio of the Aid flow from UN agencies (US$) of Mozambique in 1984 to that in 1989?
Provide a short and direct response. 0.81. What is the ratio of the Aid flow from UN agencies (US$) in Latin America(developing only) in 1985 to that in 1986?
Give a very brief answer. 1.14. What is the ratio of the Aid flow from UN agencies (US$) of Guyana in 1985 to that in 1986?
Offer a terse response. 1.42. What is the ratio of the Aid flow from UN agencies (US$) in Mozambique in 1985 to that in 1986?
Provide a short and direct response. 1.31. What is the ratio of the Aid flow from UN agencies (US$) of Latin America(developing only) in 1985 to that in 1987?
Your answer should be compact. 0.92. What is the ratio of the Aid flow from UN agencies (US$) in Guyana in 1985 to that in 1987?
Keep it short and to the point. 0.9. What is the ratio of the Aid flow from UN agencies (US$) in Mozambique in 1985 to that in 1987?
Your response must be concise. 0.94. What is the ratio of the Aid flow from UN agencies (US$) of Latin America(developing only) in 1985 to that in 1988?
Your response must be concise. 1.05. What is the ratio of the Aid flow from UN agencies (US$) of Antigua and Barbuda in 1985 to that in 1988?
Keep it short and to the point. 1.14. What is the ratio of the Aid flow from UN agencies (US$) in Guyana in 1985 to that in 1988?
Offer a very short reply. 1.42. What is the ratio of the Aid flow from UN agencies (US$) in Mozambique in 1985 to that in 1988?
Offer a very short reply. 1.94. What is the ratio of the Aid flow from UN agencies (US$) in Latin America(developing only) in 1985 to that in 1989?
Provide a short and direct response. 1.12. What is the ratio of the Aid flow from UN agencies (US$) in Antigua and Barbuda in 1985 to that in 1989?
Keep it short and to the point. 1.78. What is the ratio of the Aid flow from UN agencies (US$) in Guyana in 1985 to that in 1989?
Provide a short and direct response. 0.76. What is the ratio of the Aid flow from UN agencies (US$) of Mozambique in 1985 to that in 1989?
Your answer should be compact. 1.18. What is the ratio of the Aid flow from UN agencies (US$) of Latin America(developing only) in 1986 to that in 1987?
Your response must be concise. 0.8. What is the ratio of the Aid flow from UN agencies (US$) in Guyana in 1986 to that in 1987?
Make the answer very short. 0.63. What is the ratio of the Aid flow from UN agencies (US$) in Mozambique in 1986 to that in 1987?
Ensure brevity in your answer.  0.72. What is the ratio of the Aid flow from UN agencies (US$) in Latin America(developing only) in 1986 to that in 1988?
Your response must be concise. 0.92. What is the ratio of the Aid flow from UN agencies (US$) of Mozambique in 1986 to that in 1988?
Your response must be concise. 1.49. What is the ratio of the Aid flow from UN agencies (US$) of Latin America(developing only) in 1986 to that in 1989?
Make the answer very short. 0.98. What is the ratio of the Aid flow from UN agencies (US$) in Guyana in 1986 to that in 1989?
Offer a very short reply. 0.53. What is the ratio of the Aid flow from UN agencies (US$) in Mozambique in 1986 to that in 1989?
Ensure brevity in your answer.  0.9. What is the ratio of the Aid flow from UN agencies (US$) in Latin America(developing only) in 1987 to that in 1988?
Provide a succinct answer. 1.15. What is the ratio of the Aid flow from UN agencies (US$) of Antigua and Barbuda in 1987 to that in 1988?
Your answer should be compact. 0.07. What is the ratio of the Aid flow from UN agencies (US$) of Guyana in 1987 to that in 1988?
Provide a succinct answer. 1.58. What is the ratio of the Aid flow from UN agencies (US$) in Mozambique in 1987 to that in 1988?
Provide a succinct answer. 2.07. What is the ratio of the Aid flow from UN agencies (US$) of Latin America(developing only) in 1987 to that in 1989?
Provide a succinct answer. 1.23. What is the ratio of the Aid flow from UN agencies (US$) of Antigua and Barbuda in 1987 to that in 1989?
Give a very brief answer. 0.11. What is the ratio of the Aid flow from UN agencies (US$) of Guyana in 1987 to that in 1989?
Keep it short and to the point. 0.84. What is the ratio of the Aid flow from UN agencies (US$) of Mozambique in 1987 to that in 1989?
Keep it short and to the point. 1.25. What is the ratio of the Aid flow from UN agencies (US$) in Latin America(developing only) in 1988 to that in 1989?
Keep it short and to the point. 1.07. What is the ratio of the Aid flow from UN agencies (US$) of Antigua and Barbuda in 1988 to that in 1989?
Provide a short and direct response. 1.56. What is the ratio of the Aid flow from UN agencies (US$) in Guyana in 1988 to that in 1989?
Give a very brief answer. 0.53. What is the ratio of the Aid flow from UN agencies (US$) in Mozambique in 1988 to that in 1989?
Ensure brevity in your answer.  0.6. What is the difference between the highest and the second highest Aid flow from UN agencies (US$) of Latin America(developing only)?
Provide a short and direct response. 3.25e+06. What is the difference between the highest and the second highest Aid flow from UN agencies (US$) of Guyana?
Give a very brief answer. 2.00e+04. What is the difference between the highest and the lowest Aid flow from UN agencies (US$) of Latin America(developing only)?
Offer a terse response. 2.36e+07. What is the difference between the highest and the lowest Aid flow from UN agencies (US$) in Guyana?
Offer a very short reply. 4.30e+05. What is the difference between the highest and the lowest Aid flow from UN agencies (US$) in Mozambique?
Your response must be concise. 8.80e+05. 